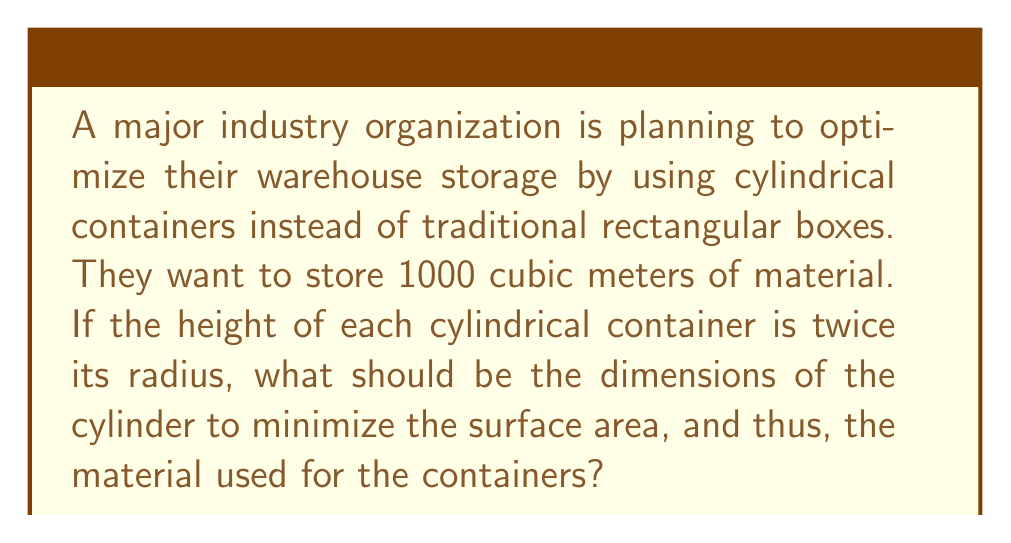Show me your answer to this math problem. To solve this problem, we need to follow these steps:

1) Let's define our variables:
   $r$ = radius of the cylinder
   $h$ = height of the cylinder

2) We're given that $h = 2r$

3) The volume of a cylinder is given by $V = \pi r^2 h$. We know this should equal 1000 m³:

   $1000 = \pi r^2 (2r) = 2\pi r^3$

4) The surface area of a cylinder is given by $S = 2\pi r^2 + 2\pi rh$. Substituting $h = 2r$:

   $S = 2\pi r^2 + 2\pi r(2r) = 2\pi r^2 + 4\pi r^2 = 6\pi r^2$

5) From step 3, we can express $r$ in terms of the volume:

   $r = \sqrt[3]{\frac{1000}{2\pi}} \approx 5.4199$ m

6) Now we can calculate the height:

   $h = 2r = 2 * 5.4199 \approx 10.8398$ m

7) To verify, let's calculate the volume:

   $V = \pi r^2 h = \pi * (5.4199)^2 * 10.8398 \approx 1000$ m³ (as required)

8) The surface area will be:

   $S = 6\pi r^2 = 6\pi * (5.4199)^2 \approx 552.9$ m²

This configuration minimizes the surface area for the given volume.
Answer: The optimal dimensions for the cylindrical container are:
Radius: $r \approx 5.42$ m
Height: $h \approx 10.84$ m
This results in a minimum surface area of approximately 552.9 m². 